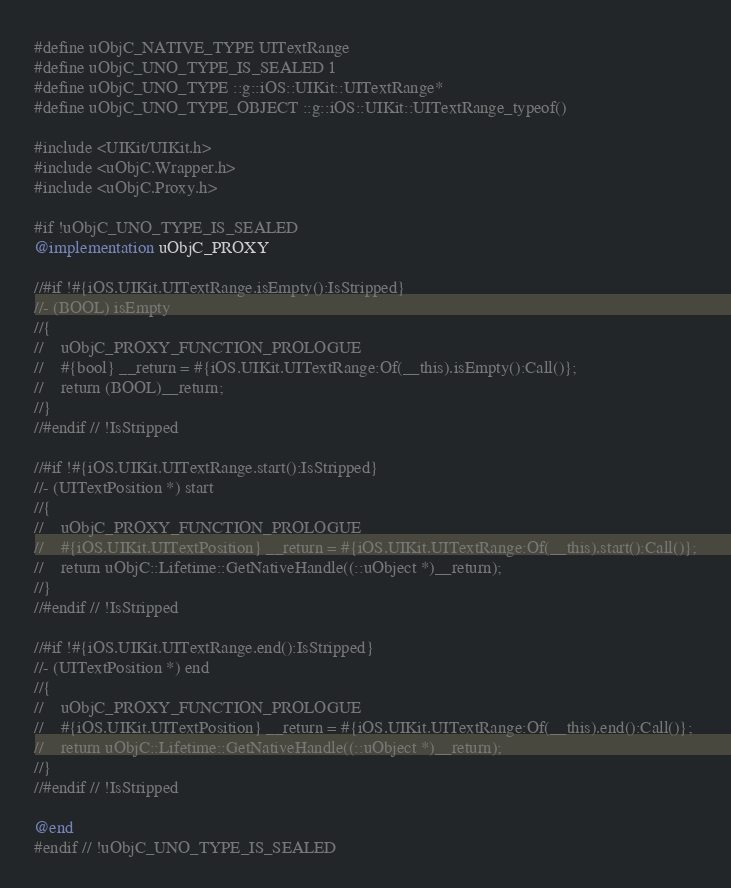Convert code to text. <code><loc_0><loc_0><loc_500><loc_500><_ObjectiveC_>#define uObjC_NATIVE_TYPE UITextRange
#define uObjC_UNO_TYPE_IS_SEALED 1
#define uObjC_UNO_TYPE ::g::iOS::UIKit::UITextRange*
#define uObjC_UNO_TYPE_OBJECT ::g::iOS::UIKit::UITextRange_typeof()

#include <UIKit/UIKit.h>
#include <uObjC.Wrapper.h>
#include <uObjC.Proxy.h>

#if !uObjC_UNO_TYPE_IS_SEALED
@implementation uObjC_PROXY

//#if !#{iOS.UIKit.UITextRange.isEmpty():IsStripped}
//- (BOOL) isEmpty
//{
//    uObjC_PROXY_FUNCTION_PROLOGUE
//    #{bool} __return = #{iOS.UIKit.UITextRange:Of(__this).isEmpty():Call()};
//    return (BOOL)__return;
//}
//#endif // !IsStripped

//#if !#{iOS.UIKit.UITextRange.start():IsStripped}
//- (UITextPosition *) start
//{
//    uObjC_PROXY_FUNCTION_PROLOGUE
//    #{iOS.UIKit.UITextPosition} __return = #{iOS.UIKit.UITextRange:Of(__this).start():Call()};
//    return uObjC::Lifetime::GetNativeHandle((::uObject *)__return);
//}
//#endif // !IsStripped

//#if !#{iOS.UIKit.UITextRange.end():IsStripped}
//- (UITextPosition *) end
//{
//    uObjC_PROXY_FUNCTION_PROLOGUE
//    #{iOS.UIKit.UITextPosition} __return = #{iOS.UIKit.UITextRange:Of(__this).end():Call()};
//    return uObjC::Lifetime::GetNativeHandle((::uObject *)__return);
//}
//#endif // !IsStripped

@end
#endif // !uObjC_UNO_TYPE_IS_SEALED
</code> 